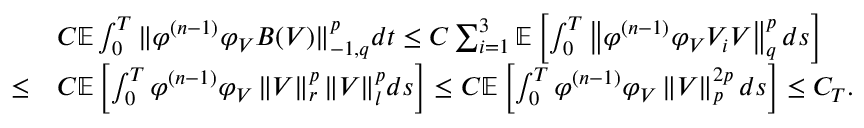<formula> <loc_0><loc_0><loc_500><loc_500>\begin{array} { r l } & { C \mathbb { E } \int _ { 0 } ^ { T } \| \varphi ^ { ( n - 1 ) } \varphi _ { V } B ( V ) \| _ { - 1 , q } ^ { p } d t \leq C \sum _ { i = 1 } ^ { 3 } \mathbb { E } \left [ \int _ { 0 } ^ { T } \left \| \varphi ^ { ( n - 1 ) } \varphi _ { V } V _ { i } V \right \| _ { q } ^ { p } d s \right ] } \\ { \leq } & { C \mathbb { E } \left [ \int _ { 0 } ^ { T } \varphi ^ { ( n - 1 ) } \varphi _ { V } \left \| V \right \| _ { r } ^ { p } \| V \| _ { l } ^ { p } d s \right ] \leq C \mathbb { E } \left [ \int _ { 0 } ^ { T } \varphi ^ { ( n - 1 ) } \varphi _ { V } \left \| V \right \| _ { p } ^ { 2 p } d s \right ] \leq C _ { T } . } \end{array}</formula> 